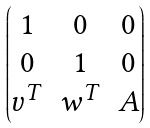Convert formula to latex. <formula><loc_0><loc_0><loc_500><loc_500>\begin{pmatrix} 1 & 0 & 0 \\ 0 & 1 & 0 \\ v ^ { T } & w ^ { T } & A \end{pmatrix}</formula> 